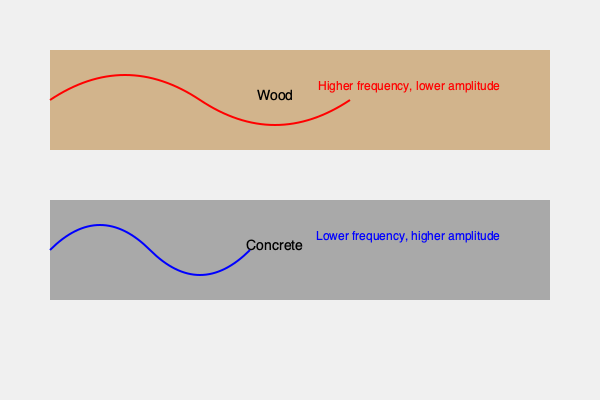Based on the sound wave visualizations for Irish dance shoes on wood and concrete surfaces, which surface would likely produce a clearer, more distinct sound for traditional Irish dance steps, and why? To answer this question, we need to analyze the acoustic properties depicted in the sound wave visualizations:

1. Wood surface:
   - The sound wave has a higher frequency (more peaks and troughs in the same distance)
   - The amplitude (height of the wave) is lower

2. Concrete surface:
   - The sound wave has a lower frequency (fewer peaks and troughs in the same distance)
   - The amplitude is higher

Now, let's consider the implications:

1. Frequency: Higher frequency sounds are generally perceived as clearer and more distinct. They produce a crisper, brighter tone.

2. Amplitude: Higher amplitude relates to louder sound. While loudness can aid in perception, it doesn't necessarily contribute to clarity.

3. Material properties:
   - Wood is more resonant and has natural acoustic properties that enhance higher frequencies.
   - Concrete is denser and reflects sound more directly, which can lead to more echo and potential muddiness in the sound.

4. Dance context:
   - Irish dance often involves intricate footwork and rhythms.
   - Clearer, more distinct sounds allow for better perception of these complex patterns.

5. Traditional preference:
   - Historically, Irish dance was often performed on wooden floors in homes or dance halls.

Considering these factors, the wood surface would likely produce a clearer, more distinct sound for traditional Irish dance steps. The higher frequency response on wood allows for better differentiation between rapid foot movements, while the lower amplitude prevents overwhelming echoes or reverberations that might muddy the sound.

The concrete surface, while producing a louder sound, may not offer the same level of clarity and distinction in the complex rhythms of Irish dance due to its lower frequency response and potential for more echo.
Answer: Wood surface, due to higher frequency response allowing clearer distinction of complex footwork patterns. 